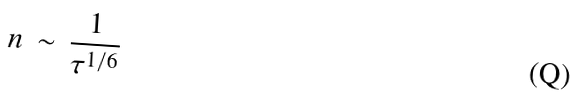Convert formula to latex. <formula><loc_0><loc_0><loc_500><loc_500>n \, \sim \, \frac { 1 } { \tau ^ { 1 / 6 } }</formula> 